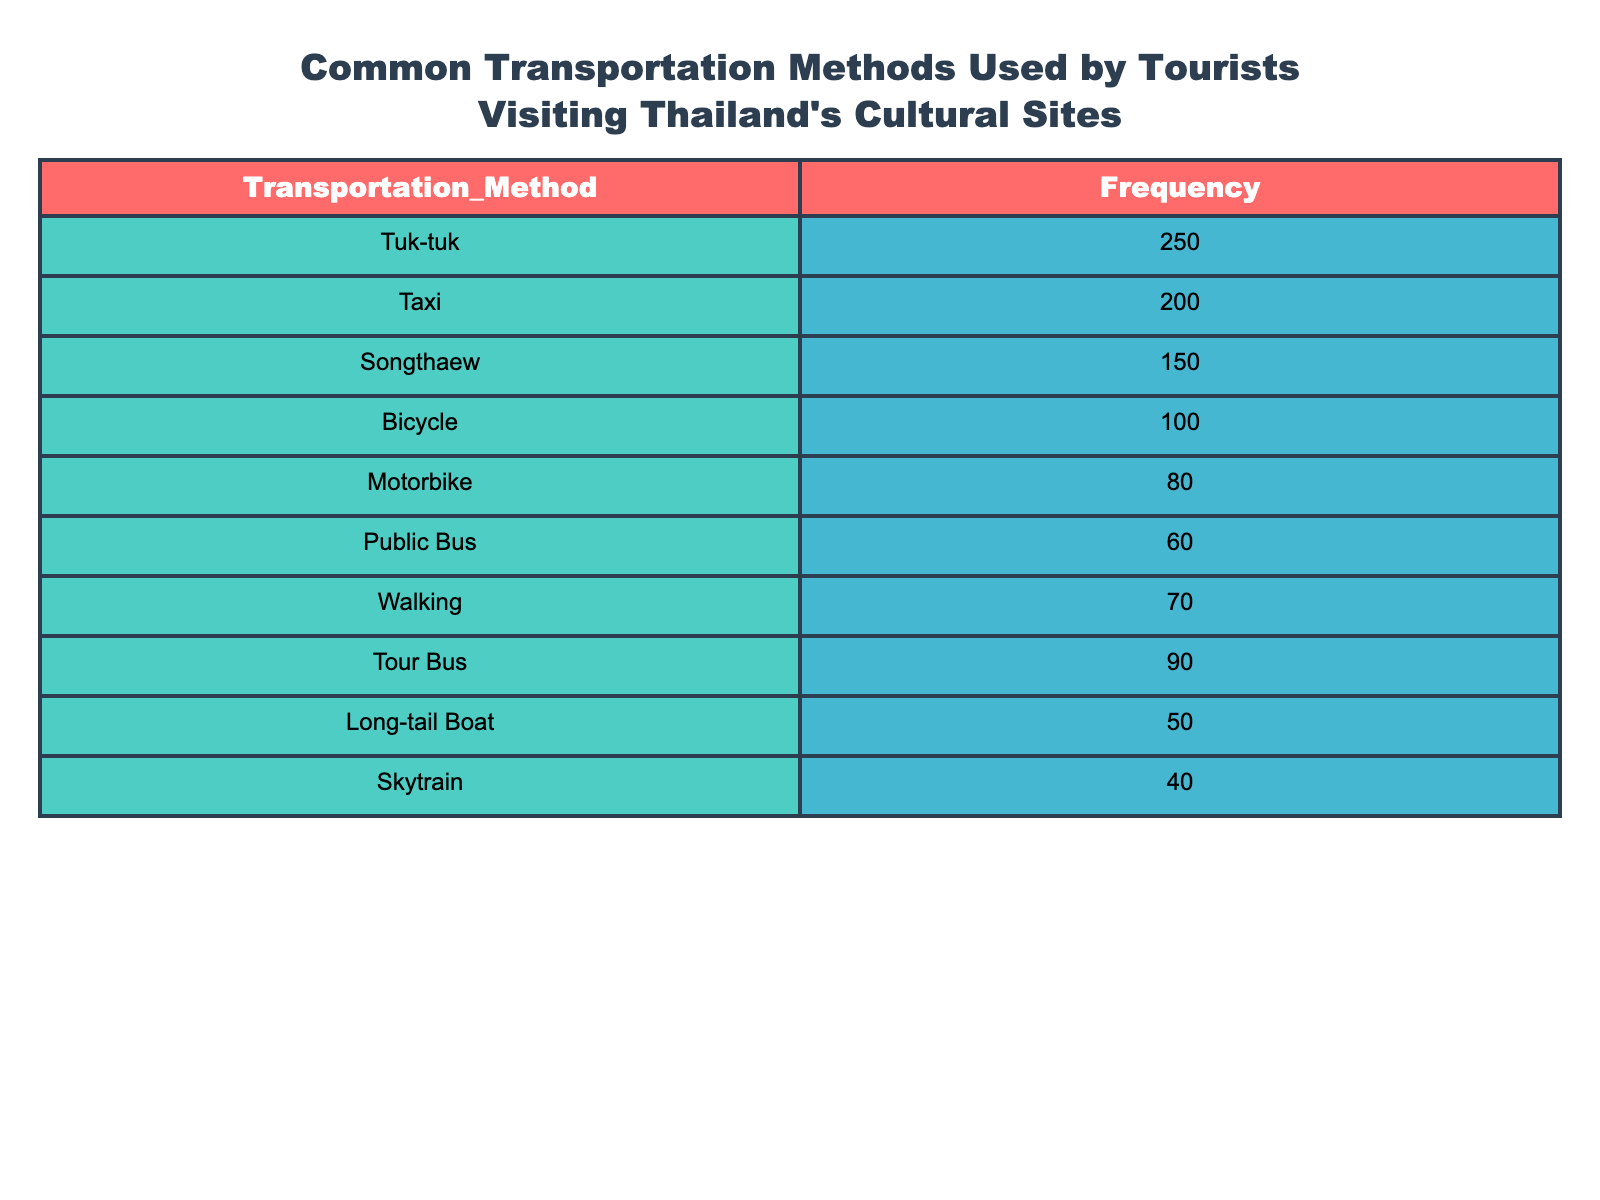What is the most commonly used transportation method by tourists in Thailand? The highest frequency value in the table is 250, indicating that Tuk-tuks are the most commonly used transportation method among tourists visiting Thailand's cultural sites.
Answer: Tuk-tuk How many tourists use bicycles for transportation compared to those who use public buses? The frequency of bicycles is 100 and the frequency for public buses is 60. Therefore, 100 - 60 = 40 more tourists use bicycles than public buses.
Answer: 40 Is the usage of Skytrain among tourists higher than that of Long-tail Boats? The frequency for Skytrain is 40 and for Long-tail Boats, it is 50. Since 40 is less than 50, Skytrain usage is not higher than Long-tail Boats.
Answer: No What is the total number of tourists using motorbikes and public buses combined? Adding the frequency of motorbikes (80) and public buses (60) gives us a total of 80 + 60 = 140 tourists using these two methods.
Answer: 140 What percentage of tourists uses taxis compared to the total transportation methods listed? The total frequency across all transportation methods is 250 + 200 + 150 + 100 + 80 + 60 + 70 + 90 + 50 + 40 = 1090. The percentage of tourists using taxis is (200/1090) * 100, which is approximately 18.35%.
Answer: 18.35% How many more tourists ride tour buses than walk to cultural sites? The frequency for tour buses is 90 and for walking, it is 70. Subtracting these values gives 90 - 70 = 20, meaning 20 more tourists ride tour buses than walk.
Answer: 20 Is it true that fewer than 100 tourists use Long-tail Boats? The frequency for Long-tail Boats is 50, which is indeed fewer than 100, making the statement true.
Answer: Yes Which transportation method has the second highest usage among tourists? The transportation method with the second highest frequency after Tuk-tuk (250) is Taxi with 200, confirming that it is the second most used method.
Answer: Taxi 